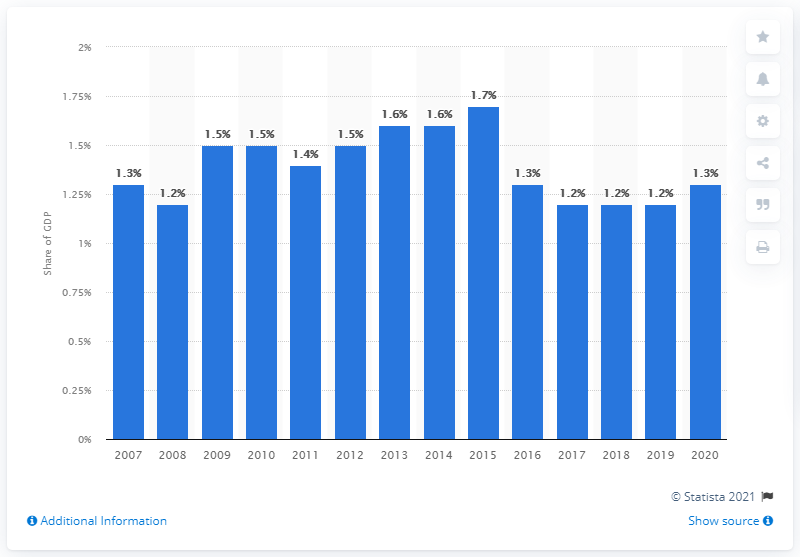Draw attention to some important aspects in this diagram. In 2020, military expenditure accounted for approximately 1.3% of Peru's Gross Domestic Product (GDP), according to recent data. 